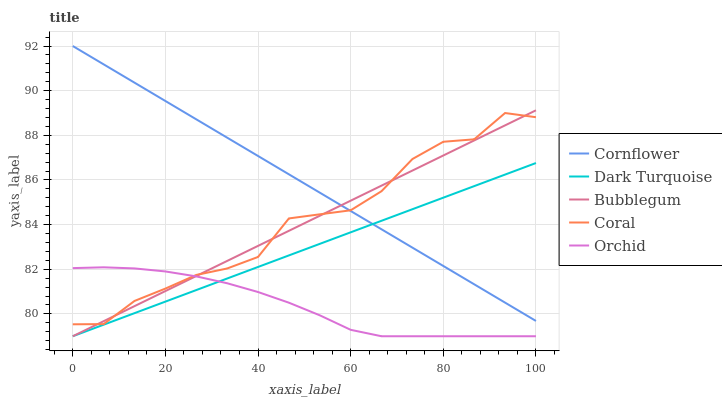Does Orchid have the minimum area under the curve?
Answer yes or no. Yes. Does Cornflower have the maximum area under the curve?
Answer yes or no. Yes. Does Coral have the minimum area under the curve?
Answer yes or no. No. Does Coral have the maximum area under the curve?
Answer yes or no. No. Is Dark Turquoise the smoothest?
Answer yes or no. Yes. Is Coral the roughest?
Answer yes or no. Yes. Is Orchid the smoothest?
Answer yes or no. No. Is Orchid the roughest?
Answer yes or no. No. Does Orchid have the lowest value?
Answer yes or no. Yes. Does Coral have the lowest value?
Answer yes or no. No. Does Cornflower have the highest value?
Answer yes or no. Yes. Does Coral have the highest value?
Answer yes or no. No. Is Dark Turquoise less than Coral?
Answer yes or no. Yes. Is Cornflower greater than Orchid?
Answer yes or no. Yes. Does Dark Turquoise intersect Orchid?
Answer yes or no. Yes. Is Dark Turquoise less than Orchid?
Answer yes or no. No. Is Dark Turquoise greater than Orchid?
Answer yes or no. No. Does Dark Turquoise intersect Coral?
Answer yes or no. No. 